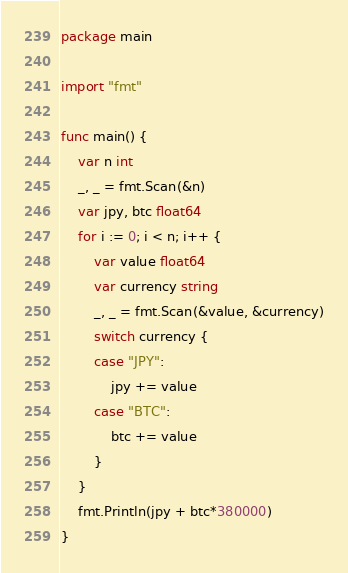Convert code to text. <code><loc_0><loc_0><loc_500><loc_500><_Go_>package main

import "fmt"

func main() {
	var n int
	_, _ = fmt.Scan(&n)
	var jpy, btc float64
	for i := 0; i < n; i++ {
		var value float64
		var currency string
		_, _ = fmt.Scan(&value, &currency)
		switch currency {
		case "JPY":
			jpy += value
		case "BTC":
			btc += value
		}
	}
	fmt.Println(jpy + btc*380000)
}
</code> 